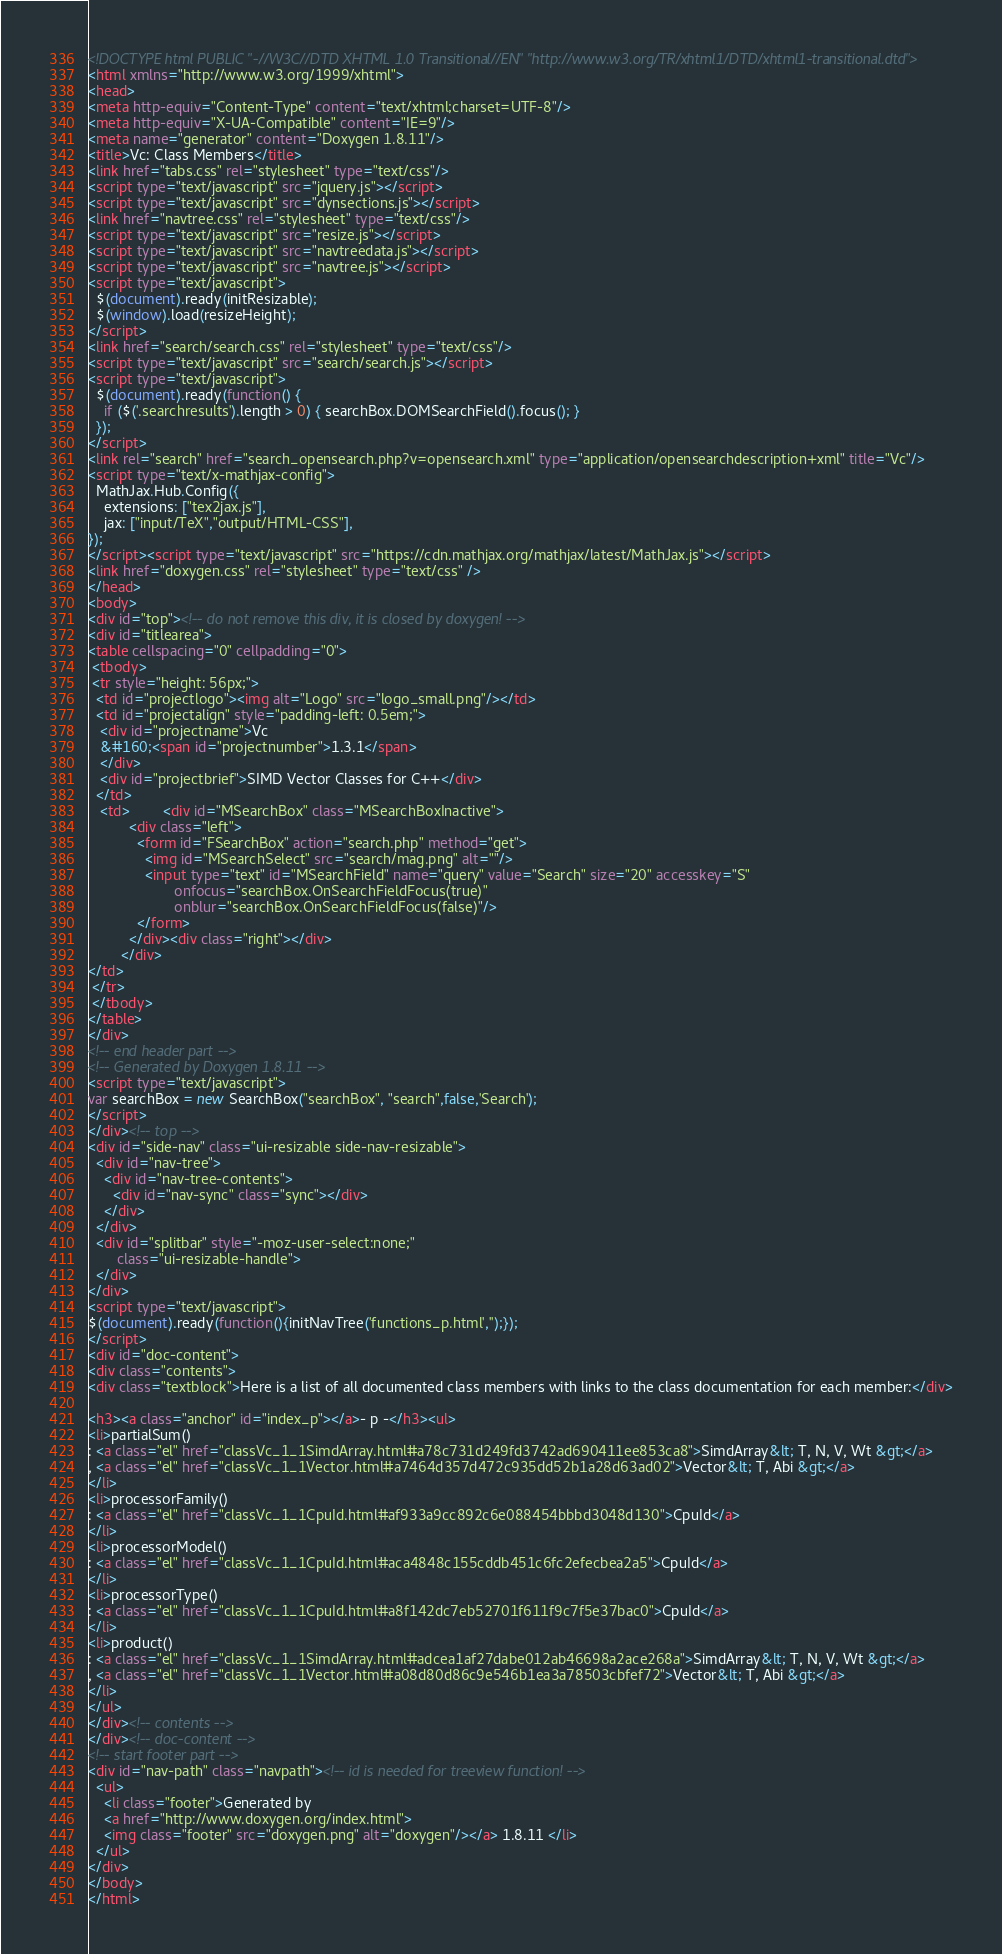<code> <loc_0><loc_0><loc_500><loc_500><_HTML_><!DOCTYPE html PUBLIC "-//W3C//DTD XHTML 1.0 Transitional//EN" "http://www.w3.org/TR/xhtml1/DTD/xhtml1-transitional.dtd">
<html xmlns="http://www.w3.org/1999/xhtml">
<head>
<meta http-equiv="Content-Type" content="text/xhtml;charset=UTF-8"/>
<meta http-equiv="X-UA-Compatible" content="IE=9"/>
<meta name="generator" content="Doxygen 1.8.11"/>
<title>Vc: Class Members</title>
<link href="tabs.css" rel="stylesheet" type="text/css"/>
<script type="text/javascript" src="jquery.js"></script>
<script type="text/javascript" src="dynsections.js"></script>
<link href="navtree.css" rel="stylesheet" type="text/css"/>
<script type="text/javascript" src="resize.js"></script>
<script type="text/javascript" src="navtreedata.js"></script>
<script type="text/javascript" src="navtree.js"></script>
<script type="text/javascript">
  $(document).ready(initResizable);
  $(window).load(resizeHeight);
</script>
<link href="search/search.css" rel="stylesheet" type="text/css"/>
<script type="text/javascript" src="search/search.js"></script>
<script type="text/javascript">
  $(document).ready(function() {
    if ($('.searchresults').length > 0) { searchBox.DOMSearchField().focus(); }
  });
</script>
<link rel="search" href="search_opensearch.php?v=opensearch.xml" type="application/opensearchdescription+xml" title="Vc"/>
<script type="text/x-mathjax-config">
  MathJax.Hub.Config({
    extensions: ["tex2jax.js"],
    jax: ["input/TeX","output/HTML-CSS"],
});
</script><script type="text/javascript" src="https://cdn.mathjax.org/mathjax/latest/MathJax.js"></script>
<link href="doxygen.css" rel="stylesheet" type="text/css" />
</head>
<body>
<div id="top"><!-- do not remove this div, it is closed by doxygen! -->
<div id="titlearea">
<table cellspacing="0" cellpadding="0">
 <tbody>
 <tr style="height: 56px;">
  <td id="projectlogo"><img alt="Logo" src="logo_small.png"/></td>
  <td id="projectalign" style="padding-left: 0.5em;">
   <div id="projectname">Vc
   &#160;<span id="projectnumber">1.3.1</span>
   </div>
   <div id="projectbrief">SIMD Vector Classes for C++</div>
  </td>
   <td>        <div id="MSearchBox" class="MSearchBoxInactive">
          <div class="left">
            <form id="FSearchBox" action="search.php" method="get">
              <img id="MSearchSelect" src="search/mag.png" alt=""/>
              <input type="text" id="MSearchField" name="query" value="Search" size="20" accesskey="S" 
                     onfocus="searchBox.OnSearchFieldFocus(true)" 
                     onblur="searchBox.OnSearchFieldFocus(false)"/>
            </form>
          </div><div class="right"></div>
        </div>
</td>
 </tr>
 </tbody>
</table>
</div>
<!-- end header part -->
<!-- Generated by Doxygen 1.8.11 -->
<script type="text/javascript">
var searchBox = new SearchBox("searchBox", "search",false,'Search');
</script>
</div><!-- top -->
<div id="side-nav" class="ui-resizable side-nav-resizable">
  <div id="nav-tree">
    <div id="nav-tree-contents">
      <div id="nav-sync" class="sync"></div>
    </div>
  </div>
  <div id="splitbar" style="-moz-user-select:none;" 
       class="ui-resizable-handle">
  </div>
</div>
<script type="text/javascript">
$(document).ready(function(){initNavTree('functions_p.html','');});
</script>
<div id="doc-content">
<div class="contents">
<div class="textblock">Here is a list of all documented class members with links to the class documentation for each member:</div>

<h3><a class="anchor" id="index_p"></a>- p -</h3><ul>
<li>partialSum()
: <a class="el" href="classVc_1_1SimdArray.html#a78c731d249fd3742ad690411ee853ca8">SimdArray&lt; T, N, V, Wt &gt;</a>
, <a class="el" href="classVc_1_1Vector.html#a7464d357d472c935dd52b1a28d63ad02">Vector&lt; T, Abi &gt;</a>
</li>
<li>processorFamily()
: <a class="el" href="classVc_1_1CpuId.html#af933a9cc892c6e088454bbbd3048d130">CpuId</a>
</li>
<li>processorModel()
: <a class="el" href="classVc_1_1CpuId.html#aca4848c155cddb451c6fc2efecbea2a5">CpuId</a>
</li>
<li>processorType()
: <a class="el" href="classVc_1_1CpuId.html#a8f142dc7eb52701f611f9c7f5e37bac0">CpuId</a>
</li>
<li>product()
: <a class="el" href="classVc_1_1SimdArray.html#adcea1af27dabe012ab46698a2ace268a">SimdArray&lt; T, N, V, Wt &gt;</a>
, <a class="el" href="classVc_1_1Vector.html#a08d80d86c9e546b1ea3a78503cbfef72">Vector&lt; T, Abi &gt;</a>
</li>
</ul>
</div><!-- contents -->
</div><!-- doc-content -->
<!-- start footer part -->
<div id="nav-path" class="navpath"><!-- id is needed for treeview function! -->
  <ul>
    <li class="footer">Generated by
    <a href="http://www.doxygen.org/index.html">
    <img class="footer" src="doxygen.png" alt="doxygen"/></a> 1.8.11 </li>
  </ul>
</div>
</body>
</html>
</code> 